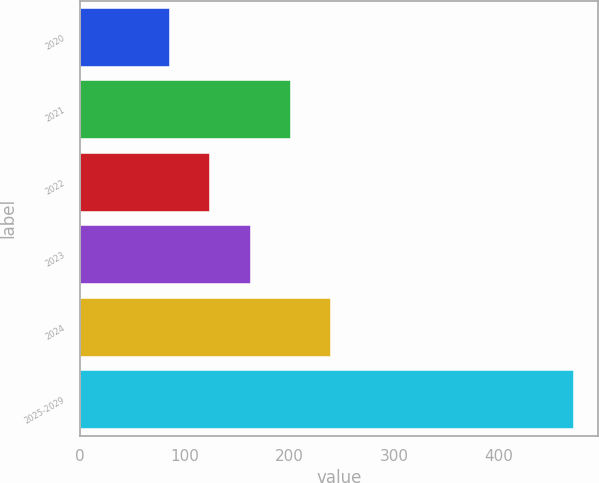<chart> <loc_0><loc_0><loc_500><loc_500><bar_chart><fcel>2020<fcel>2021<fcel>2022<fcel>2023<fcel>2024<fcel>2025-2029<nl><fcel>84.9<fcel>200.73<fcel>123.51<fcel>162.12<fcel>239.34<fcel>471<nl></chart> 